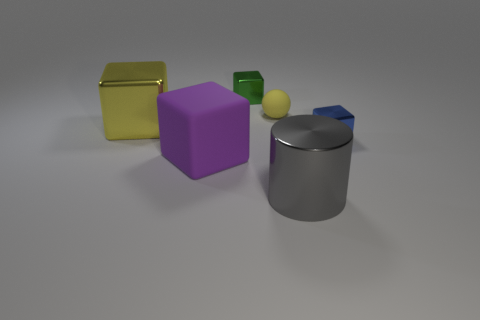There is a matte thing that is the same size as the green shiny block; what shape is it?
Ensure brevity in your answer.  Sphere. What shape is the matte object in front of the matte thing behind the metal block that is right of the big cylinder?
Provide a succinct answer. Cube. Is the number of gray objects that are behind the big gray cylinder the same as the number of large green rubber objects?
Offer a very short reply. Yes. Is the size of the green cube the same as the sphere?
Provide a short and direct response. Yes. How many metallic objects are tiny cyan objects or small green cubes?
Give a very brief answer. 1. There is a green thing that is the same size as the blue object; what is its material?
Provide a succinct answer. Metal. How many other things are there of the same material as the yellow sphere?
Ensure brevity in your answer.  1. Are there fewer small green blocks that are left of the small blue metallic thing than large cubes?
Your response must be concise. Yes. Do the large yellow thing and the gray thing have the same shape?
Give a very brief answer. No. What size is the yellow object that is on the right side of the tiny metallic cube that is to the left of the tiny thing in front of the big yellow thing?
Provide a short and direct response. Small. 